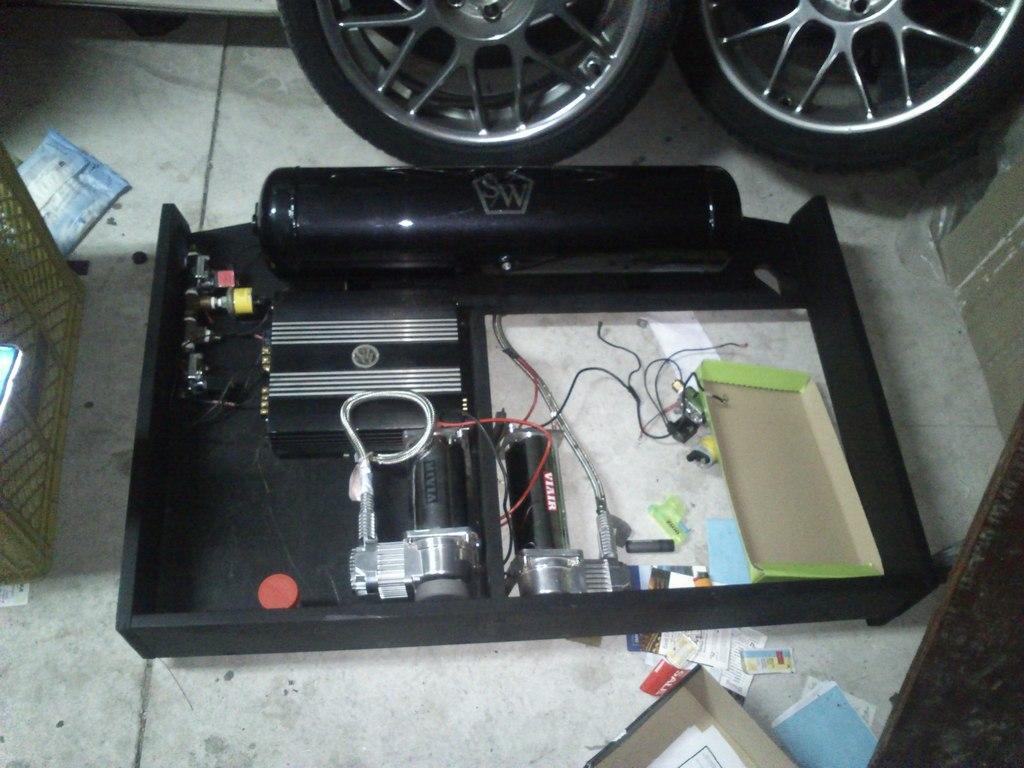In one or two sentences, can you explain what this image depicts? In the center of the image we can see an electrical equipment. On the left there is a basket and we can see things placed on the floor. 